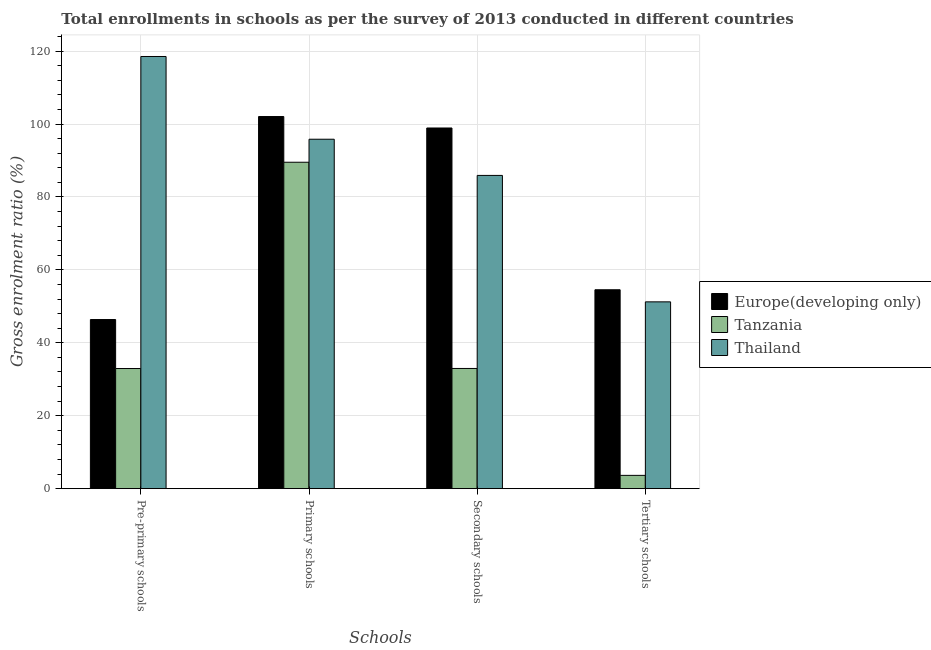How many different coloured bars are there?
Keep it short and to the point. 3. Are the number of bars on each tick of the X-axis equal?
Provide a short and direct response. Yes. How many bars are there on the 4th tick from the left?
Offer a very short reply. 3. What is the label of the 2nd group of bars from the left?
Make the answer very short. Primary schools. What is the gross enrolment ratio in tertiary schools in Europe(developing only)?
Your response must be concise. 54.55. Across all countries, what is the maximum gross enrolment ratio in pre-primary schools?
Offer a very short reply. 118.52. Across all countries, what is the minimum gross enrolment ratio in tertiary schools?
Ensure brevity in your answer.  3.65. In which country was the gross enrolment ratio in primary schools maximum?
Ensure brevity in your answer.  Europe(developing only). In which country was the gross enrolment ratio in pre-primary schools minimum?
Offer a very short reply. Tanzania. What is the total gross enrolment ratio in tertiary schools in the graph?
Give a very brief answer. 109.43. What is the difference between the gross enrolment ratio in tertiary schools in Europe(developing only) and that in Tanzania?
Give a very brief answer. 50.9. What is the difference between the gross enrolment ratio in primary schools in Europe(developing only) and the gross enrolment ratio in secondary schools in Thailand?
Offer a terse response. 16.14. What is the average gross enrolment ratio in primary schools per country?
Provide a short and direct response. 95.8. What is the difference between the gross enrolment ratio in tertiary schools and gross enrolment ratio in primary schools in Europe(developing only)?
Make the answer very short. -47.5. What is the ratio of the gross enrolment ratio in pre-primary schools in Tanzania to that in Europe(developing only)?
Your answer should be very brief. 0.71. Is the gross enrolment ratio in tertiary schools in Tanzania less than that in Europe(developing only)?
Your answer should be compact. Yes. Is the difference between the gross enrolment ratio in tertiary schools in Tanzania and Thailand greater than the difference between the gross enrolment ratio in pre-primary schools in Tanzania and Thailand?
Ensure brevity in your answer.  Yes. What is the difference between the highest and the second highest gross enrolment ratio in pre-primary schools?
Keep it short and to the point. 72.14. What is the difference between the highest and the lowest gross enrolment ratio in tertiary schools?
Your answer should be very brief. 50.9. In how many countries, is the gross enrolment ratio in primary schools greater than the average gross enrolment ratio in primary schools taken over all countries?
Offer a very short reply. 2. Is the sum of the gross enrolment ratio in tertiary schools in Thailand and Europe(developing only) greater than the maximum gross enrolment ratio in pre-primary schools across all countries?
Make the answer very short. No. What does the 1st bar from the left in Primary schools represents?
Offer a very short reply. Europe(developing only). What does the 3rd bar from the right in Primary schools represents?
Make the answer very short. Europe(developing only). Does the graph contain any zero values?
Offer a terse response. No. Where does the legend appear in the graph?
Provide a succinct answer. Center right. How are the legend labels stacked?
Give a very brief answer. Vertical. What is the title of the graph?
Give a very brief answer. Total enrollments in schools as per the survey of 2013 conducted in different countries. What is the label or title of the X-axis?
Offer a terse response. Schools. What is the Gross enrolment ratio (%) of Europe(developing only) in Pre-primary schools?
Your answer should be very brief. 46.38. What is the Gross enrolment ratio (%) of Tanzania in Pre-primary schools?
Your answer should be very brief. 32.95. What is the Gross enrolment ratio (%) of Thailand in Pre-primary schools?
Provide a short and direct response. 118.52. What is the Gross enrolment ratio (%) of Europe(developing only) in Primary schools?
Ensure brevity in your answer.  102.05. What is the Gross enrolment ratio (%) of Tanzania in Primary schools?
Ensure brevity in your answer.  89.52. What is the Gross enrolment ratio (%) in Thailand in Primary schools?
Ensure brevity in your answer.  95.83. What is the Gross enrolment ratio (%) of Europe(developing only) in Secondary schools?
Your answer should be compact. 98.91. What is the Gross enrolment ratio (%) of Tanzania in Secondary schools?
Provide a short and direct response. 32.97. What is the Gross enrolment ratio (%) in Thailand in Secondary schools?
Your answer should be compact. 85.91. What is the Gross enrolment ratio (%) of Europe(developing only) in Tertiary schools?
Provide a short and direct response. 54.55. What is the Gross enrolment ratio (%) of Tanzania in Tertiary schools?
Ensure brevity in your answer.  3.65. What is the Gross enrolment ratio (%) of Thailand in Tertiary schools?
Ensure brevity in your answer.  51.23. Across all Schools, what is the maximum Gross enrolment ratio (%) in Europe(developing only)?
Keep it short and to the point. 102.05. Across all Schools, what is the maximum Gross enrolment ratio (%) of Tanzania?
Give a very brief answer. 89.52. Across all Schools, what is the maximum Gross enrolment ratio (%) in Thailand?
Provide a short and direct response. 118.52. Across all Schools, what is the minimum Gross enrolment ratio (%) of Europe(developing only)?
Your answer should be compact. 46.38. Across all Schools, what is the minimum Gross enrolment ratio (%) of Tanzania?
Your answer should be compact. 3.65. Across all Schools, what is the minimum Gross enrolment ratio (%) in Thailand?
Provide a short and direct response. 51.23. What is the total Gross enrolment ratio (%) in Europe(developing only) in the graph?
Offer a very short reply. 301.89. What is the total Gross enrolment ratio (%) in Tanzania in the graph?
Provide a short and direct response. 159.09. What is the total Gross enrolment ratio (%) in Thailand in the graph?
Your response must be concise. 351.49. What is the difference between the Gross enrolment ratio (%) of Europe(developing only) in Pre-primary schools and that in Primary schools?
Ensure brevity in your answer.  -55.67. What is the difference between the Gross enrolment ratio (%) of Tanzania in Pre-primary schools and that in Primary schools?
Provide a succinct answer. -56.57. What is the difference between the Gross enrolment ratio (%) of Thailand in Pre-primary schools and that in Primary schools?
Provide a succinct answer. 22.69. What is the difference between the Gross enrolment ratio (%) in Europe(developing only) in Pre-primary schools and that in Secondary schools?
Ensure brevity in your answer.  -52.53. What is the difference between the Gross enrolment ratio (%) in Tanzania in Pre-primary schools and that in Secondary schools?
Your response must be concise. -0.02. What is the difference between the Gross enrolment ratio (%) in Thailand in Pre-primary schools and that in Secondary schools?
Provide a short and direct response. 32.61. What is the difference between the Gross enrolment ratio (%) in Europe(developing only) in Pre-primary schools and that in Tertiary schools?
Provide a short and direct response. -8.17. What is the difference between the Gross enrolment ratio (%) of Tanzania in Pre-primary schools and that in Tertiary schools?
Ensure brevity in your answer.  29.3. What is the difference between the Gross enrolment ratio (%) in Thailand in Pre-primary schools and that in Tertiary schools?
Ensure brevity in your answer.  67.29. What is the difference between the Gross enrolment ratio (%) of Europe(developing only) in Primary schools and that in Secondary schools?
Your response must be concise. 3.14. What is the difference between the Gross enrolment ratio (%) of Tanzania in Primary schools and that in Secondary schools?
Ensure brevity in your answer.  56.55. What is the difference between the Gross enrolment ratio (%) in Thailand in Primary schools and that in Secondary schools?
Ensure brevity in your answer.  9.92. What is the difference between the Gross enrolment ratio (%) in Europe(developing only) in Primary schools and that in Tertiary schools?
Provide a succinct answer. 47.5. What is the difference between the Gross enrolment ratio (%) in Tanzania in Primary schools and that in Tertiary schools?
Your response must be concise. 85.87. What is the difference between the Gross enrolment ratio (%) of Thailand in Primary schools and that in Tertiary schools?
Your answer should be very brief. 44.6. What is the difference between the Gross enrolment ratio (%) of Europe(developing only) in Secondary schools and that in Tertiary schools?
Your answer should be compact. 44.36. What is the difference between the Gross enrolment ratio (%) of Tanzania in Secondary schools and that in Tertiary schools?
Offer a very short reply. 29.32. What is the difference between the Gross enrolment ratio (%) of Thailand in Secondary schools and that in Tertiary schools?
Keep it short and to the point. 34.67. What is the difference between the Gross enrolment ratio (%) in Europe(developing only) in Pre-primary schools and the Gross enrolment ratio (%) in Tanzania in Primary schools?
Offer a terse response. -43.14. What is the difference between the Gross enrolment ratio (%) of Europe(developing only) in Pre-primary schools and the Gross enrolment ratio (%) of Thailand in Primary schools?
Offer a very short reply. -49.45. What is the difference between the Gross enrolment ratio (%) of Tanzania in Pre-primary schools and the Gross enrolment ratio (%) of Thailand in Primary schools?
Keep it short and to the point. -62.88. What is the difference between the Gross enrolment ratio (%) in Europe(developing only) in Pre-primary schools and the Gross enrolment ratio (%) in Tanzania in Secondary schools?
Give a very brief answer. 13.41. What is the difference between the Gross enrolment ratio (%) of Europe(developing only) in Pre-primary schools and the Gross enrolment ratio (%) of Thailand in Secondary schools?
Your answer should be compact. -39.53. What is the difference between the Gross enrolment ratio (%) in Tanzania in Pre-primary schools and the Gross enrolment ratio (%) in Thailand in Secondary schools?
Keep it short and to the point. -52.96. What is the difference between the Gross enrolment ratio (%) in Europe(developing only) in Pre-primary schools and the Gross enrolment ratio (%) in Tanzania in Tertiary schools?
Make the answer very short. 42.73. What is the difference between the Gross enrolment ratio (%) of Europe(developing only) in Pre-primary schools and the Gross enrolment ratio (%) of Thailand in Tertiary schools?
Give a very brief answer. -4.85. What is the difference between the Gross enrolment ratio (%) in Tanzania in Pre-primary schools and the Gross enrolment ratio (%) in Thailand in Tertiary schools?
Make the answer very short. -18.29. What is the difference between the Gross enrolment ratio (%) in Europe(developing only) in Primary schools and the Gross enrolment ratio (%) in Tanzania in Secondary schools?
Provide a short and direct response. 69.08. What is the difference between the Gross enrolment ratio (%) of Europe(developing only) in Primary schools and the Gross enrolment ratio (%) of Thailand in Secondary schools?
Your response must be concise. 16.14. What is the difference between the Gross enrolment ratio (%) of Tanzania in Primary schools and the Gross enrolment ratio (%) of Thailand in Secondary schools?
Your answer should be very brief. 3.61. What is the difference between the Gross enrolment ratio (%) in Europe(developing only) in Primary schools and the Gross enrolment ratio (%) in Tanzania in Tertiary schools?
Your answer should be very brief. 98.4. What is the difference between the Gross enrolment ratio (%) of Europe(developing only) in Primary schools and the Gross enrolment ratio (%) of Thailand in Tertiary schools?
Offer a terse response. 50.82. What is the difference between the Gross enrolment ratio (%) in Tanzania in Primary schools and the Gross enrolment ratio (%) in Thailand in Tertiary schools?
Offer a very short reply. 38.28. What is the difference between the Gross enrolment ratio (%) in Europe(developing only) in Secondary schools and the Gross enrolment ratio (%) in Tanzania in Tertiary schools?
Offer a terse response. 95.26. What is the difference between the Gross enrolment ratio (%) of Europe(developing only) in Secondary schools and the Gross enrolment ratio (%) of Thailand in Tertiary schools?
Ensure brevity in your answer.  47.67. What is the difference between the Gross enrolment ratio (%) in Tanzania in Secondary schools and the Gross enrolment ratio (%) in Thailand in Tertiary schools?
Your answer should be very brief. -18.27. What is the average Gross enrolment ratio (%) in Europe(developing only) per Schools?
Your response must be concise. 75.47. What is the average Gross enrolment ratio (%) of Tanzania per Schools?
Offer a very short reply. 39.77. What is the average Gross enrolment ratio (%) of Thailand per Schools?
Offer a terse response. 87.87. What is the difference between the Gross enrolment ratio (%) of Europe(developing only) and Gross enrolment ratio (%) of Tanzania in Pre-primary schools?
Ensure brevity in your answer.  13.43. What is the difference between the Gross enrolment ratio (%) of Europe(developing only) and Gross enrolment ratio (%) of Thailand in Pre-primary schools?
Your answer should be compact. -72.14. What is the difference between the Gross enrolment ratio (%) of Tanzania and Gross enrolment ratio (%) of Thailand in Pre-primary schools?
Make the answer very short. -85.57. What is the difference between the Gross enrolment ratio (%) of Europe(developing only) and Gross enrolment ratio (%) of Tanzania in Primary schools?
Your answer should be very brief. 12.53. What is the difference between the Gross enrolment ratio (%) in Europe(developing only) and Gross enrolment ratio (%) in Thailand in Primary schools?
Make the answer very short. 6.22. What is the difference between the Gross enrolment ratio (%) of Tanzania and Gross enrolment ratio (%) of Thailand in Primary schools?
Your response must be concise. -6.31. What is the difference between the Gross enrolment ratio (%) in Europe(developing only) and Gross enrolment ratio (%) in Tanzania in Secondary schools?
Your response must be concise. 65.94. What is the difference between the Gross enrolment ratio (%) of Europe(developing only) and Gross enrolment ratio (%) of Thailand in Secondary schools?
Your response must be concise. 13. What is the difference between the Gross enrolment ratio (%) in Tanzania and Gross enrolment ratio (%) in Thailand in Secondary schools?
Provide a succinct answer. -52.94. What is the difference between the Gross enrolment ratio (%) in Europe(developing only) and Gross enrolment ratio (%) in Tanzania in Tertiary schools?
Make the answer very short. 50.9. What is the difference between the Gross enrolment ratio (%) in Europe(developing only) and Gross enrolment ratio (%) in Thailand in Tertiary schools?
Your answer should be compact. 3.32. What is the difference between the Gross enrolment ratio (%) of Tanzania and Gross enrolment ratio (%) of Thailand in Tertiary schools?
Offer a very short reply. -47.58. What is the ratio of the Gross enrolment ratio (%) in Europe(developing only) in Pre-primary schools to that in Primary schools?
Your answer should be very brief. 0.45. What is the ratio of the Gross enrolment ratio (%) of Tanzania in Pre-primary schools to that in Primary schools?
Provide a succinct answer. 0.37. What is the ratio of the Gross enrolment ratio (%) in Thailand in Pre-primary schools to that in Primary schools?
Make the answer very short. 1.24. What is the ratio of the Gross enrolment ratio (%) in Europe(developing only) in Pre-primary schools to that in Secondary schools?
Ensure brevity in your answer.  0.47. What is the ratio of the Gross enrolment ratio (%) of Thailand in Pre-primary schools to that in Secondary schools?
Provide a succinct answer. 1.38. What is the ratio of the Gross enrolment ratio (%) in Europe(developing only) in Pre-primary schools to that in Tertiary schools?
Give a very brief answer. 0.85. What is the ratio of the Gross enrolment ratio (%) in Tanzania in Pre-primary schools to that in Tertiary schools?
Your answer should be very brief. 9.02. What is the ratio of the Gross enrolment ratio (%) of Thailand in Pre-primary schools to that in Tertiary schools?
Provide a succinct answer. 2.31. What is the ratio of the Gross enrolment ratio (%) of Europe(developing only) in Primary schools to that in Secondary schools?
Your response must be concise. 1.03. What is the ratio of the Gross enrolment ratio (%) in Tanzania in Primary schools to that in Secondary schools?
Provide a short and direct response. 2.72. What is the ratio of the Gross enrolment ratio (%) in Thailand in Primary schools to that in Secondary schools?
Offer a very short reply. 1.12. What is the ratio of the Gross enrolment ratio (%) of Europe(developing only) in Primary schools to that in Tertiary schools?
Provide a succinct answer. 1.87. What is the ratio of the Gross enrolment ratio (%) of Tanzania in Primary schools to that in Tertiary schools?
Ensure brevity in your answer.  24.52. What is the ratio of the Gross enrolment ratio (%) of Thailand in Primary schools to that in Tertiary schools?
Ensure brevity in your answer.  1.87. What is the ratio of the Gross enrolment ratio (%) in Europe(developing only) in Secondary schools to that in Tertiary schools?
Offer a very short reply. 1.81. What is the ratio of the Gross enrolment ratio (%) of Tanzania in Secondary schools to that in Tertiary schools?
Provide a short and direct response. 9.03. What is the ratio of the Gross enrolment ratio (%) in Thailand in Secondary schools to that in Tertiary schools?
Your answer should be compact. 1.68. What is the difference between the highest and the second highest Gross enrolment ratio (%) in Europe(developing only)?
Offer a terse response. 3.14. What is the difference between the highest and the second highest Gross enrolment ratio (%) of Tanzania?
Offer a very short reply. 56.55. What is the difference between the highest and the second highest Gross enrolment ratio (%) of Thailand?
Provide a succinct answer. 22.69. What is the difference between the highest and the lowest Gross enrolment ratio (%) of Europe(developing only)?
Make the answer very short. 55.67. What is the difference between the highest and the lowest Gross enrolment ratio (%) in Tanzania?
Offer a terse response. 85.87. What is the difference between the highest and the lowest Gross enrolment ratio (%) in Thailand?
Offer a terse response. 67.29. 